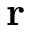Convert formula to latex. <formula><loc_0><loc_0><loc_500><loc_500>r</formula> 